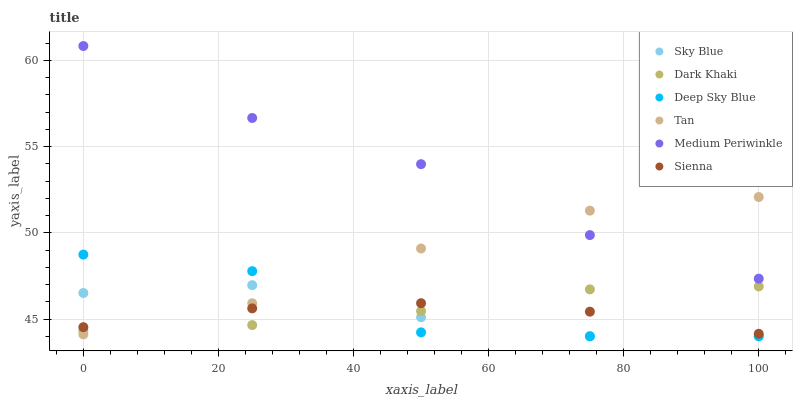Does Sienna have the minimum area under the curve?
Answer yes or no. Yes. Does Medium Periwinkle have the maximum area under the curve?
Answer yes or no. Yes. Does Dark Khaki have the minimum area under the curve?
Answer yes or no. No. Does Dark Khaki have the maximum area under the curve?
Answer yes or no. No. Is Dark Khaki the smoothest?
Answer yes or no. Yes. Is Deep Sky Blue the roughest?
Answer yes or no. Yes. Is Medium Periwinkle the smoothest?
Answer yes or no. No. Is Medium Periwinkle the roughest?
Answer yes or no. No. Does Deep Sky Blue have the lowest value?
Answer yes or no. Yes. Does Dark Khaki have the lowest value?
Answer yes or no. No. Does Medium Periwinkle have the highest value?
Answer yes or no. Yes. Does Dark Khaki have the highest value?
Answer yes or no. No. Is Deep Sky Blue less than Medium Periwinkle?
Answer yes or no. Yes. Is Medium Periwinkle greater than Sky Blue?
Answer yes or no. Yes. Does Sienna intersect Dark Khaki?
Answer yes or no. Yes. Is Sienna less than Dark Khaki?
Answer yes or no. No. Is Sienna greater than Dark Khaki?
Answer yes or no. No. Does Deep Sky Blue intersect Medium Periwinkle?
Answer yes or no. No. 